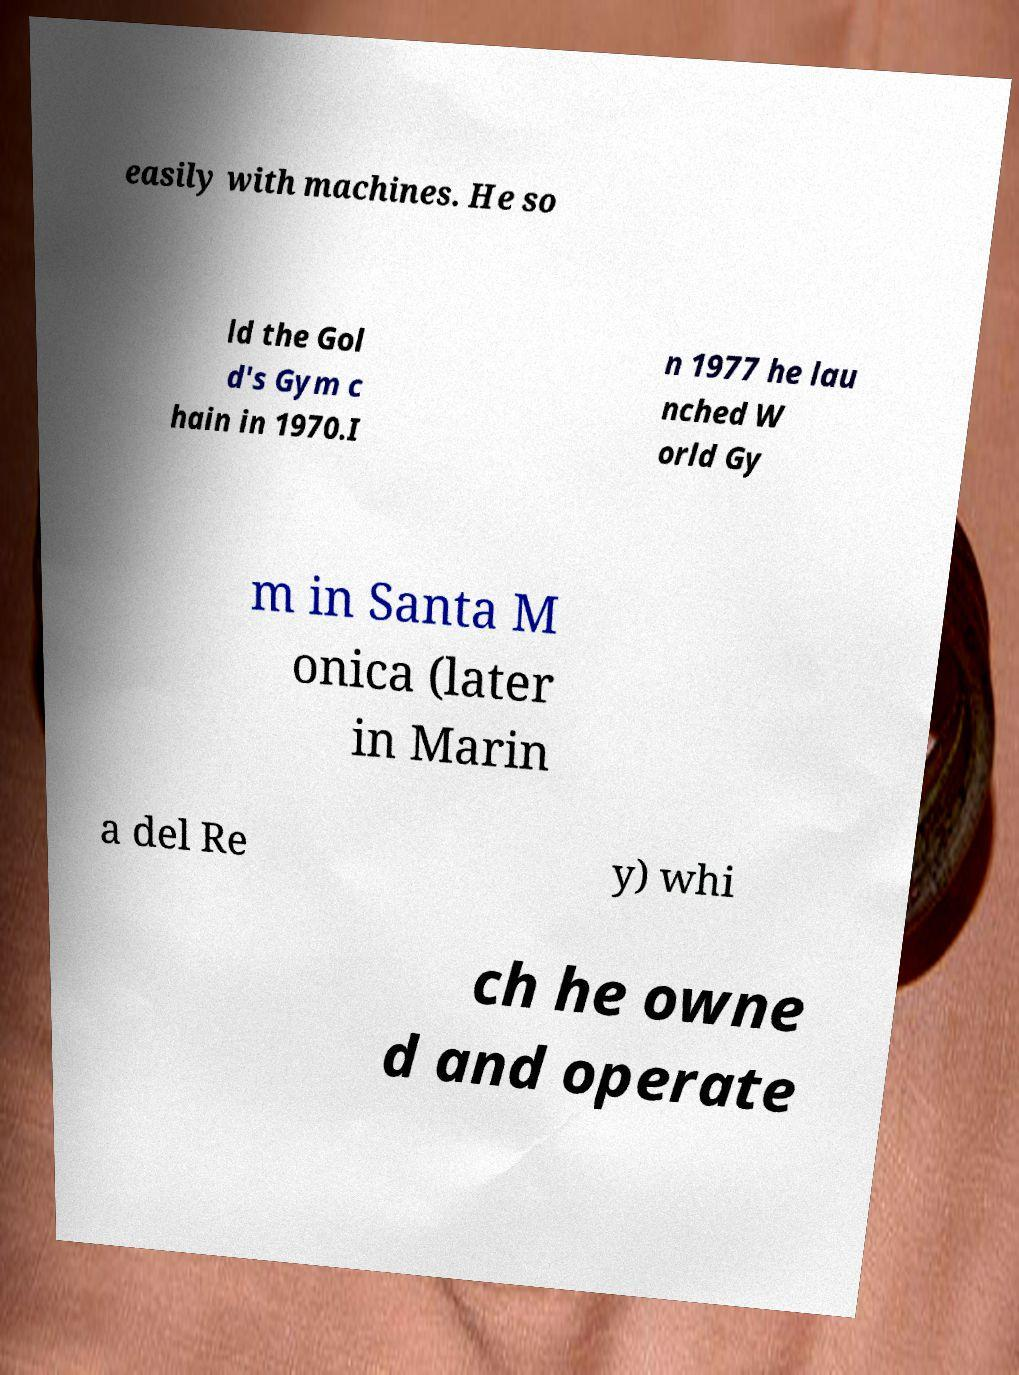Please read and relay the text visible in this image. What does it say? easily with machines. He so ld the Gol d's Gym c hain in 1970.I n 1977 he lau nched W orld Gy m in Santa M onica (later in Marin a del Re y) whi ch he owne d and operate 